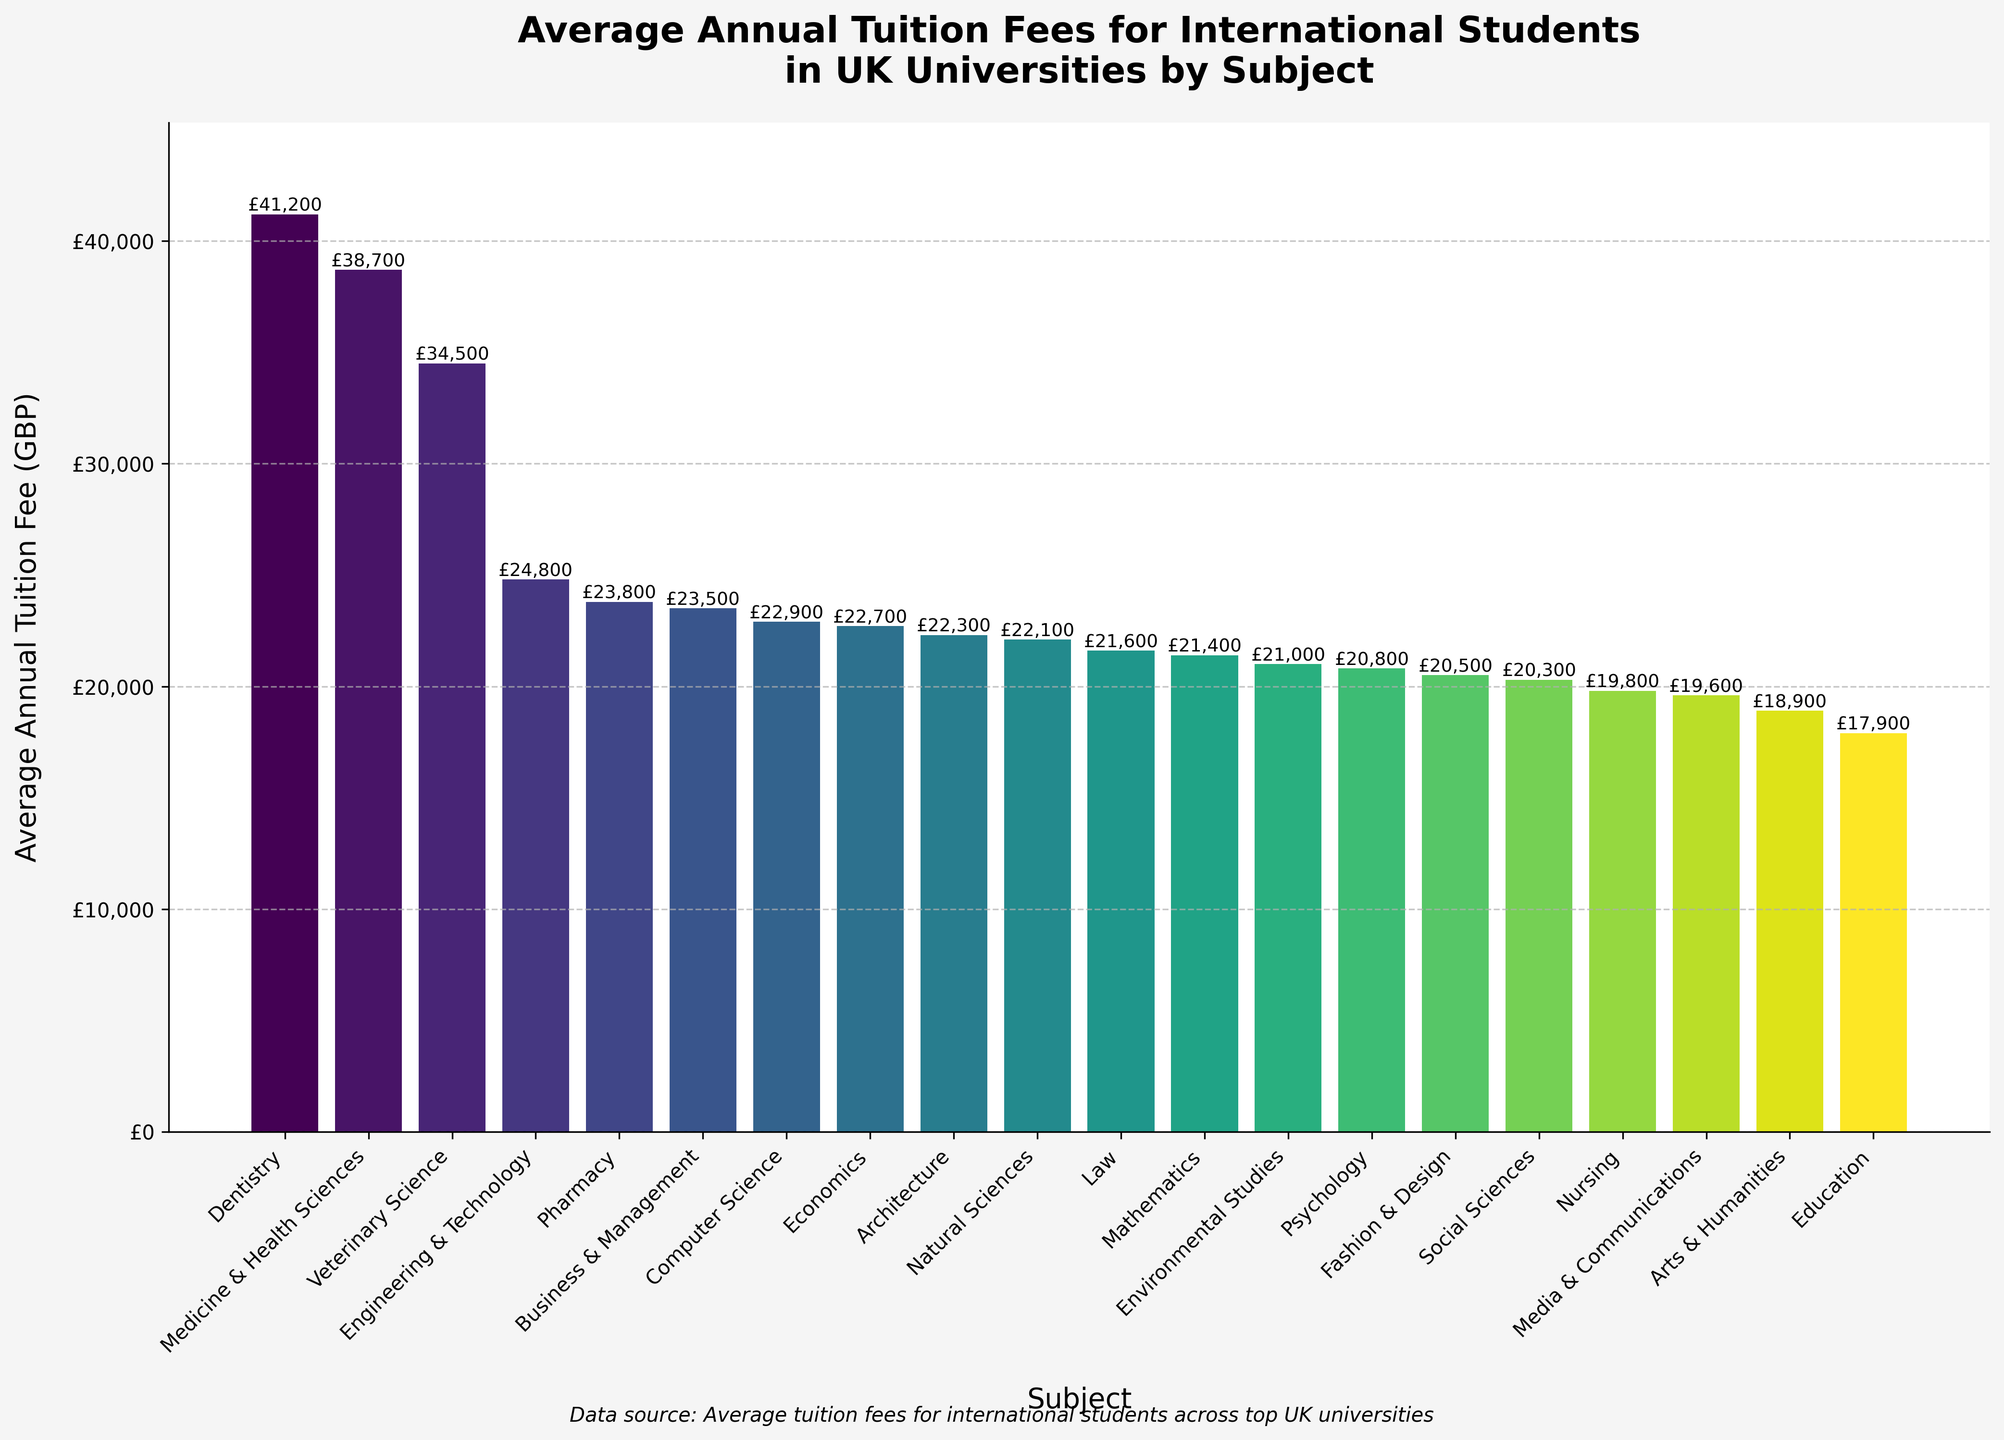What is the average annual tuition fee for the most expensive subject? The bar chart shows that 'Dentistry' has the highest average annual tuition fee. The value on the top of the 'Dentistry' bar states it clearly.
Answer: £41,200 Which subject has the lowest average annual tuition fee and what is its value? The shortest bar in the chart represents 'Education'. The value on top of the 'Education' bar indicates the average annual tuition fee.
Answer: £17,900 How much more expensive is Medicine & Health Sciences compared to Economics? To find the difference, subtract the average annual tuition fee for Economics from that of Medicine & Health Sciences: £38,700 - £22,700 = £16,000.
Answer: £16,000 Which subjects have tuition fees between £20,000 and £23,000? Subjects falling within this range based on the bar heights and corresponding values are: Computer Science (£22,900), Pharmacy (£23,800), Natural Sciences (£22,100), Architecture (£22,300), Law (£21,600), Environmental Studies (£21,000), Mathematics (£21,400), Fashion & Design (£20,500), and Social Sciences (£20,300).
Answer: Computer Science, Pharmacy, Natural Sciences, Architecture, Law, Environmental Studies, Mathematics, Fashion & Design, Social Sciences What’s the combined average annual tuition fee for Business & Management and Veterinary Science? Add the average annual tuition fees for both subjects: £23,500 + £34,500 = £58,000.
Answer: £58,000 If the tuition fee for Nursing was increased by £3,000, what would the new fee be? Add £3,000 to the current fee for Nursing: £19,800 + £3,000 = £22,800.
Answer: £22,800 Which three subjects have the closest average annual tuition fees? By examining the heights and values of the bars, 'Computer Science' (£22,900), 'Economics' (£22,700), and 'Natural Sciences' (£22,100) have closely related fees.
Answer: Computer Science, Economics, Natural Sciences How does the average annual tuition fee for Social Sciences compare to that for Psychology? The average annual tuition fee for Social Sciences is £20,300, while for Psychology it is £20,800. Since £20,300 is less than £20,800, Social Sciences is cheaper.
Answer: Social Sciences is cheaper What's the average tuition fee of three subjects: Media & Communications, Environmental Studies, and Fashion & Design? Add the values for these subjects and then divide by 3 to find the average: (£19,600 + £21,000 + £20,500) / 3 = £20,366.67.
Answer: £20,366.67 